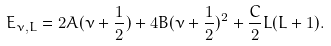<formula> <loc_0><loc_0><loc_500><loc_500>E _ { \nu , L } = 2 A ( \nu + \frac { 1 } { 2 } ) + 4 B ( \nu + \frac { 1 } { 2 } ) ^ { 2 } + \frac { C } { 2 } L ( L + 1 ) .</formula> 